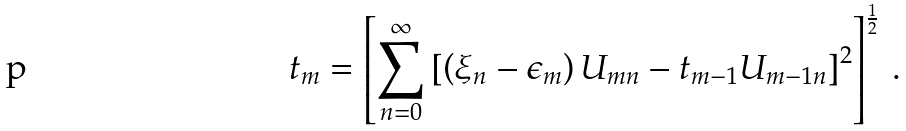<formula> <loc_0><loc_0><loc_500><loc_500>t _ { m } = \left [ \sum _ { n = 0 } ^ { \infty } \left [ \left ( \xi _ { n } - \epsilon _ { m } \right ) U _ { m n } - t _ { m - 1 } U _ { m - 1 n } \right ] ^ { 2 } \right ] ^ { \frac { 1 } { 2 } } \, .</formula> 